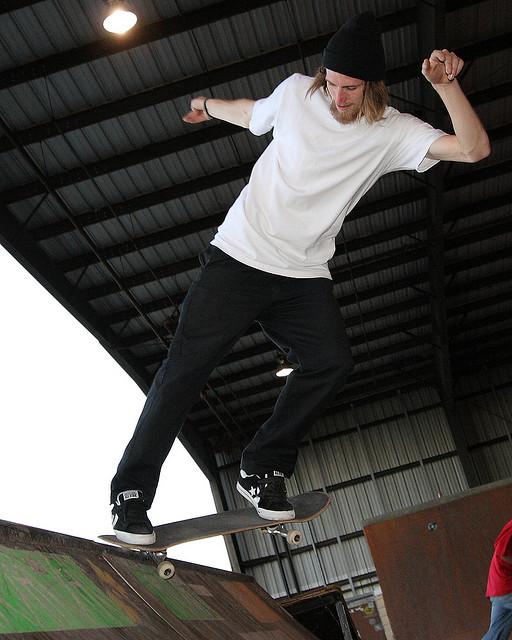What color is the man's shirt?
Write a very short answer. White. Is this young man riding on only two wheels?
Write a very short answer. Yes. Where is the man playing?
Keep it brief. Skateboarding. What design is on the skateboard?
Keep it brief. Plain. What color is the man's pants?
Answer briefly. Black. How many wheels are in this image?
Give a very brief answer. 2. 